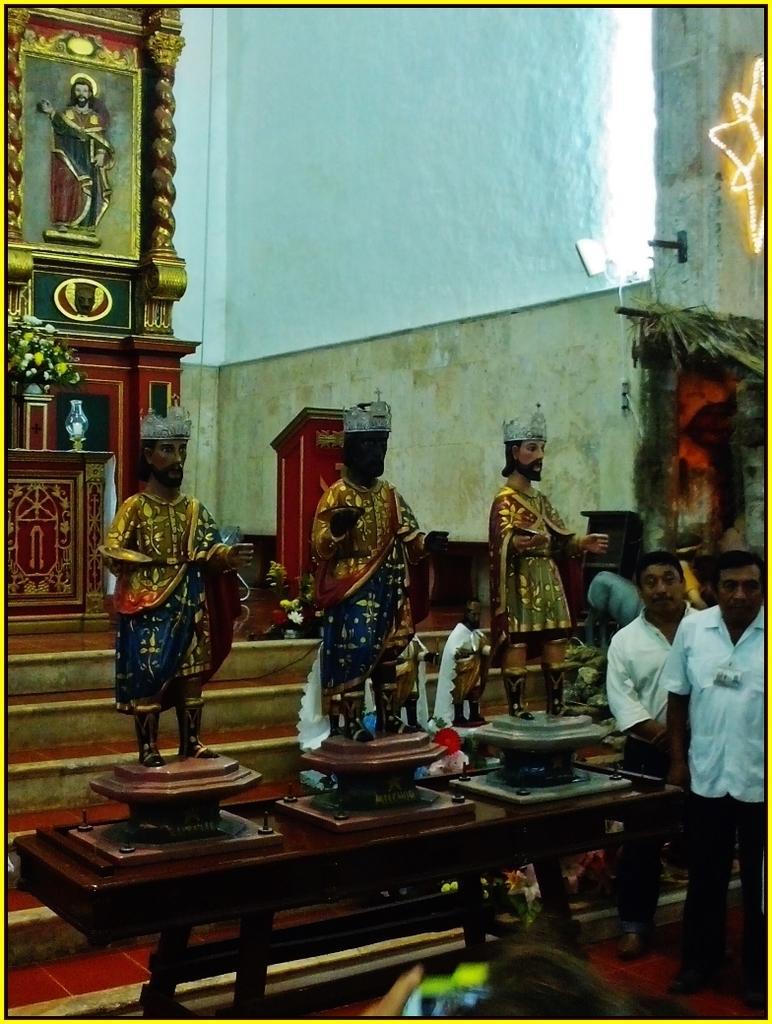Describe this image in one or two sentences. In this image I can see the few people standing and wearing the white and black color dresses. To the side these people I can see the statues of the persons. In the back I can see the bouquet, vase and also the frame to the wall. 